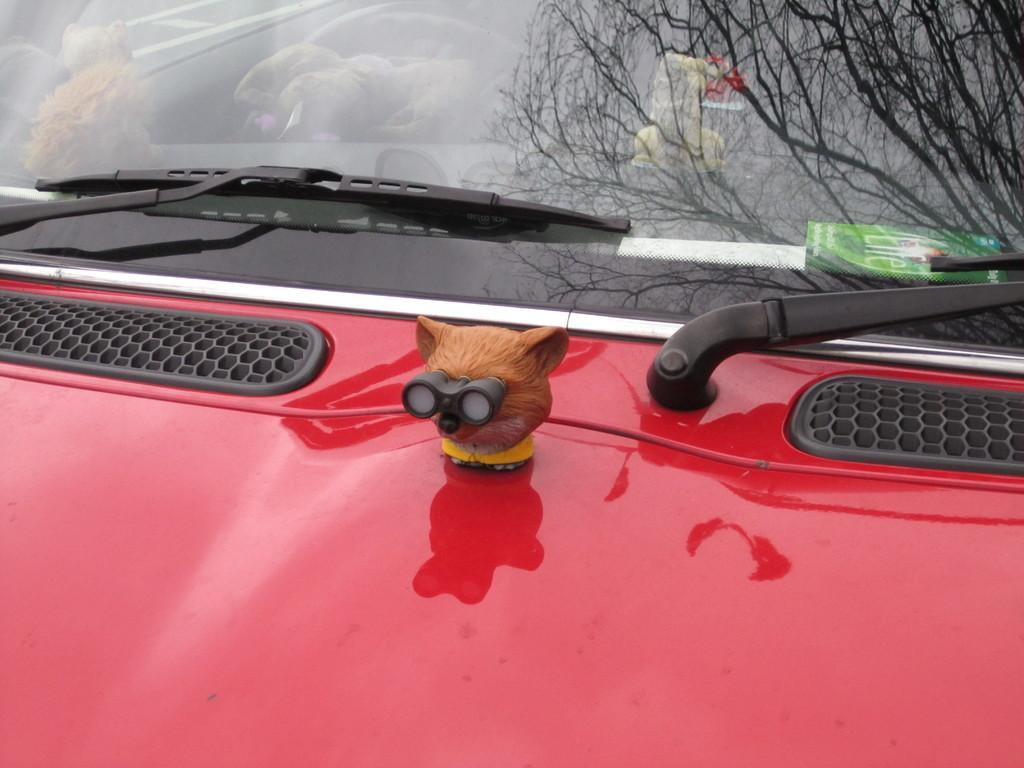What type of object is the main subject of the image? There is a vehicle in the image. What color is the vehicle? The vehicle is red in color. Are there any additional items on the vehicle? Yes, there is a toy on the vehicle. What can be seen in the reflection of the image? The reflection of a tree is visible in the image. What type of badge is the driver wearing in the image? There is no driver present in the image, and therefore no badge can be observed. What is the best way to reach the destination shown in the image? The image does not provide information about a destination or the best way to reach it. 